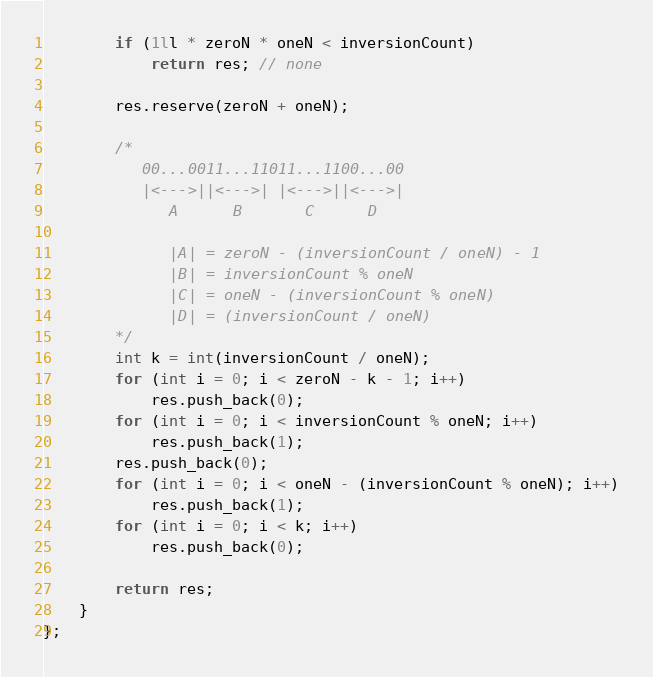Convert code to text. <code><loc_0><loc_0><loc_500><loc_500><_C_>        if (1ll * zeroN * oneN < inversionCount)
            return res; // none

        res.reserve(zeroN + oneN);

        /*
           00...0011...11011...1100...00
           |<--->||<--->| |<--->||<--->|
              A      B       C      D

              |A| = zeroN - (inversionCount / oneN) - 1
              |B| = inversionCount % oneN
              |C| = oneN - (inversionCount % oneN)
              |D| = (inversionCount / oneN)
        */
        int k = int(inversionCount / oneN);
        for (int i = 0; i < zeroN - k - 1; i++)
            res.push_back(0);
        for (int i = 0; i < inversionCount % oneN; i++)
            res.push_back(1);
        res.push_back(0);
        for (int i = 0; i < oneN - (inversionCount % oneN); i++)
            res.push_back(1);
        for (int i = 0; i < k; i++)
            res.push_back(0);

        return res;
    }
};
</code> 